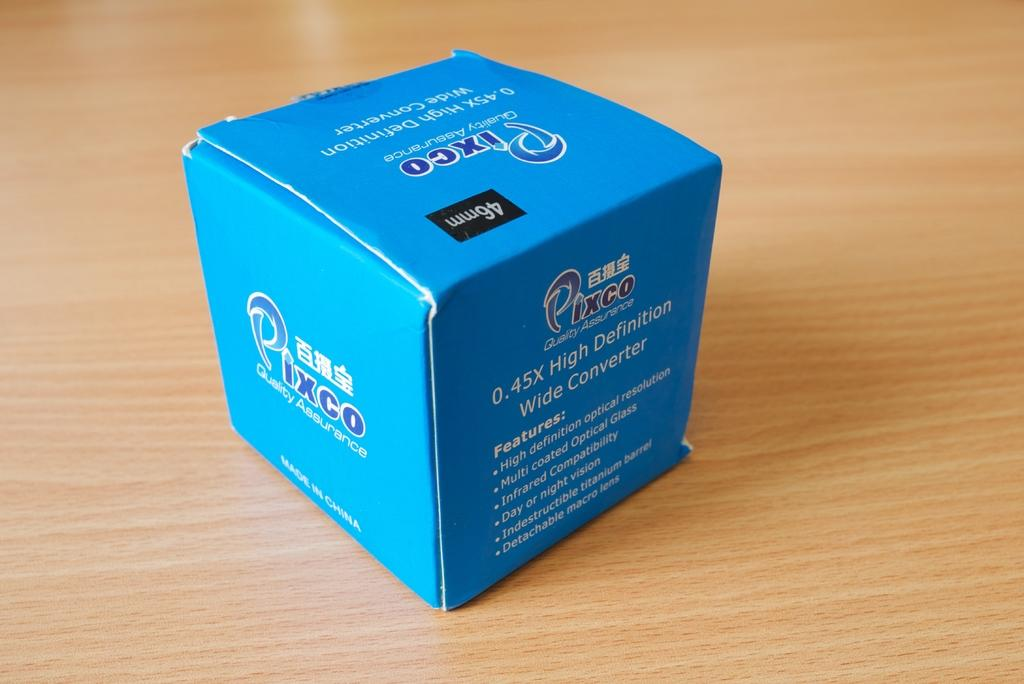Provide a one-sentence caption for the provided image. a blue box from the brand pixco and in chinese. 